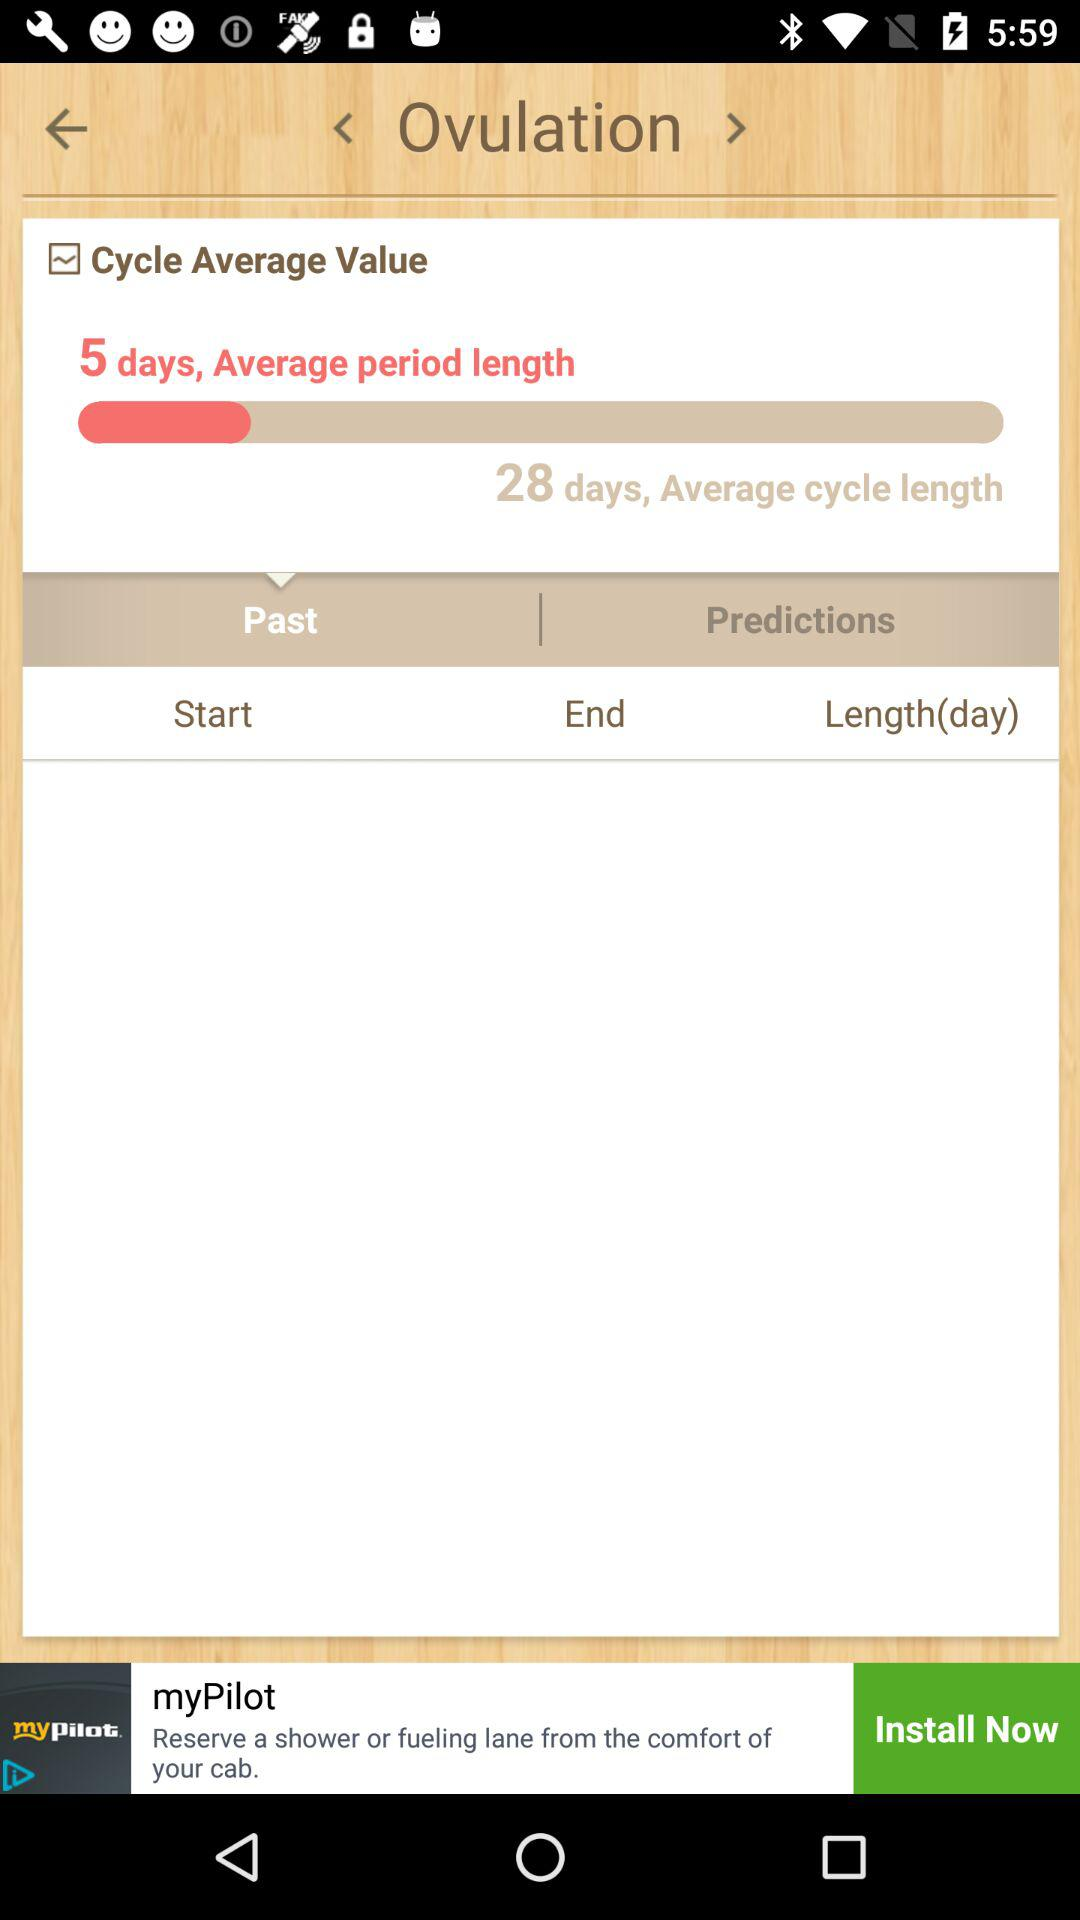Which tab is selected? The selected tab is Past. 